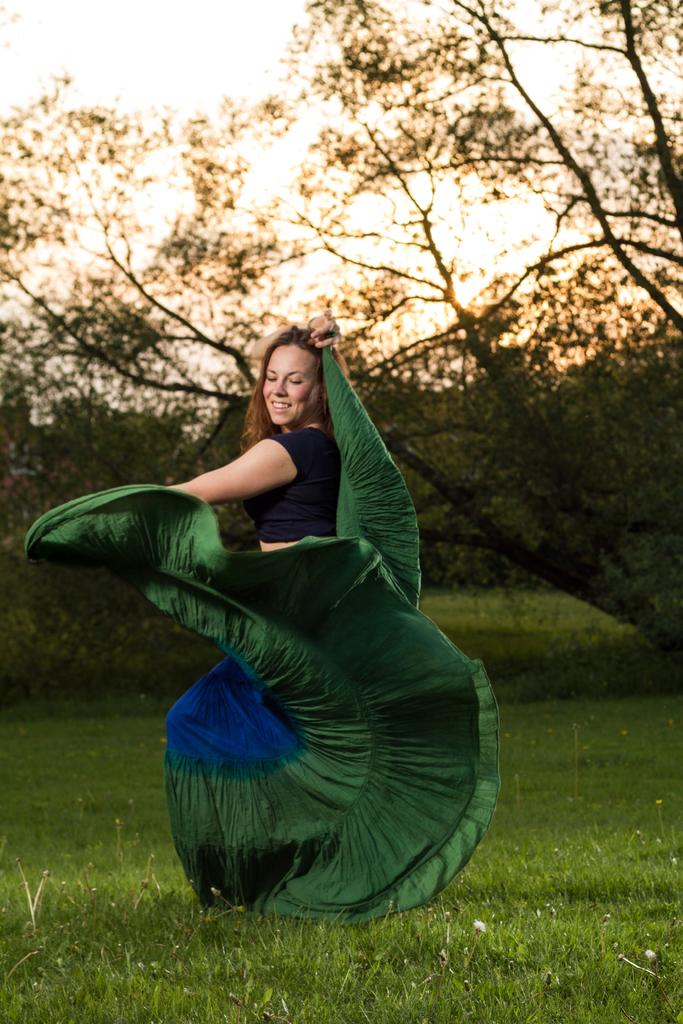Who is present in the image? There is a woman in the image. What is the woman standing on? The woman is standing on the grass. What can be seen in the background of the image? There are trees and the sky visible in the background of the image. What type of mine is visible in the image? There is no mine present in the image. What animals can be seen at the zoo in the image? There is no zoo or animals present in the image. 